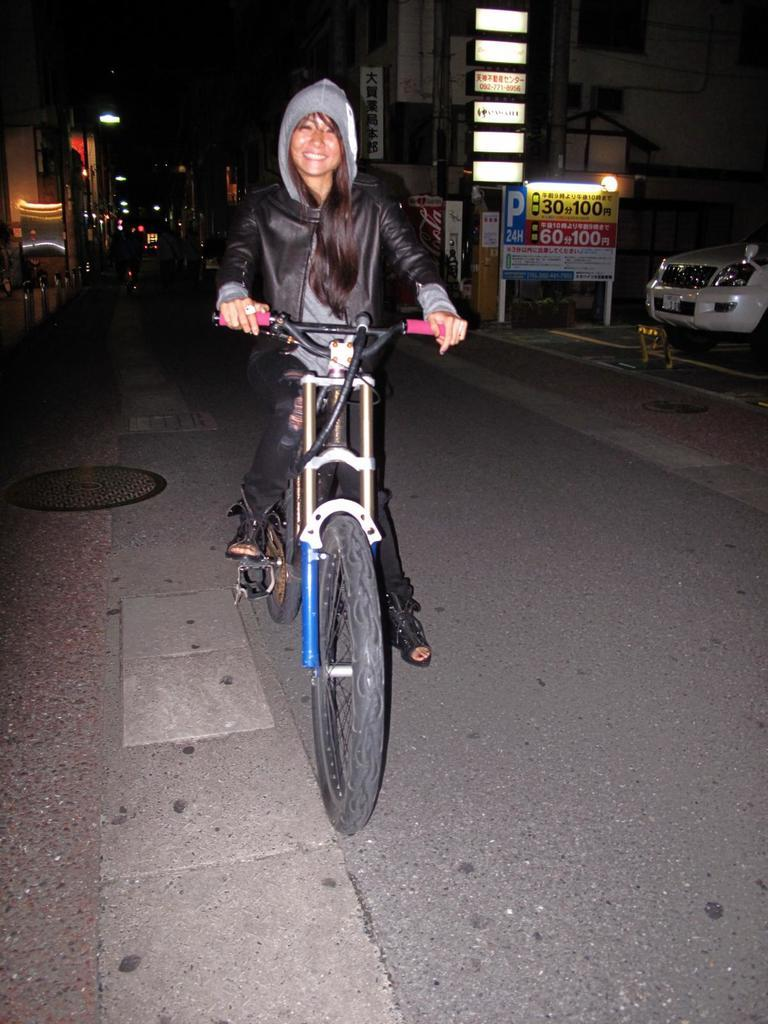Who is the main subject in the image? There is a woman in the image. What is the woman doing in the image? The woman is riding a cycle. How does the woman appear to feel in the image? There is a smile on the woman's face, suggesting she is happy or enjoying herself. What can be seen in the background of the image? There is a vehicle and buildings in the background of the image. What type of juice is the woman drinking while riding the cycle in the image? There is no juice present in the image; the woman is riding a cycle with a smile on her face. What is the reason for the woman riding the cycle in the image? The image does not provide information about the reason for the woman riding the cycle. 